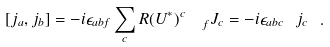<formula> <loc_0><loc_0><loc_500><loc_500>[ j _ { a } , j _ { b } ] = - i \epsilon _ { a b f } \sum _ { c } R ( U ^ { * } ) ^ { c } _ { \ \ f } J _ { c } = - i \epsilon _ { a b c } \ j _ { c } \ .</formula> 